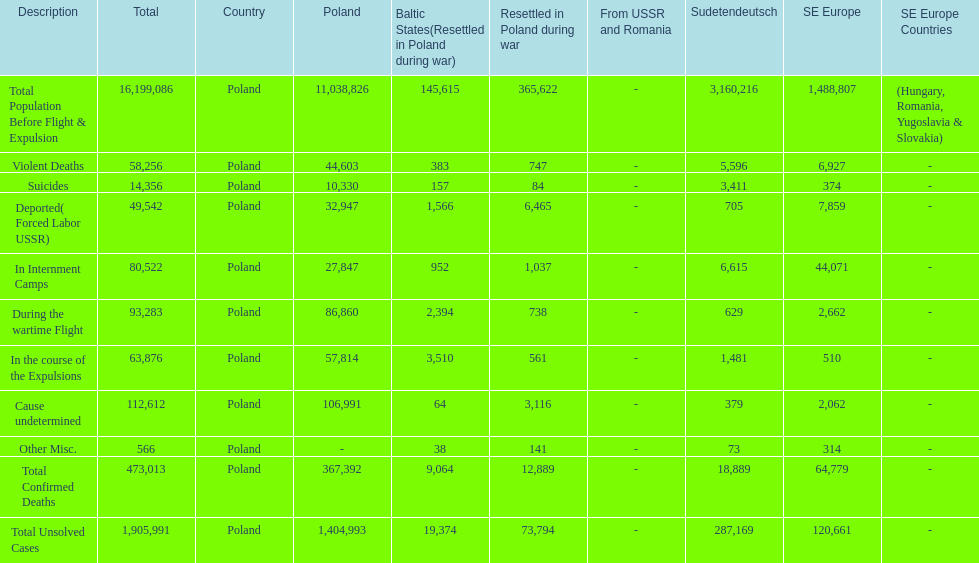Which country had the larger death tole? Poland. 